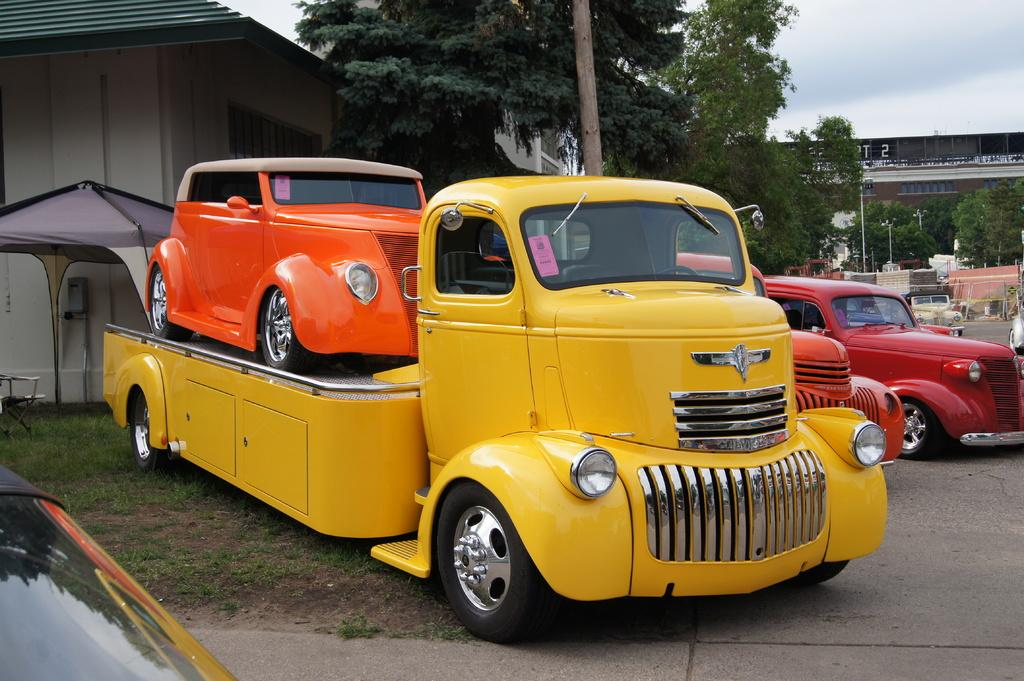What type of vehicles are on the grass in the image? The facts do not specify the type of vehicles, but there are vehicles on the grass in the image. What can be seen in the background of the image? There is a house and trees visible in the background of the image. Where is the hose located in the image? There is no hose present in the image. How many babies are crawling on the grass in the image? There are no babies present in the image. 